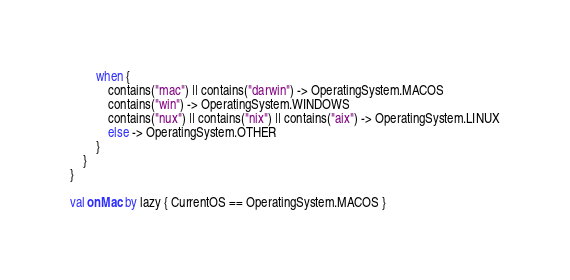<code> <loc_0><loc_0><loc_500><loc_500><_Kotlin_>        when {
            contains("mac") || contains("darwin") -> OperatingSystem.MACOS
            contains("win") -> OperatingSystem.WINDOWS
            contains("nux") || contains("nix") || contains("aix") -> OperatingSystem.LINUX
            else -> OperatingSystem.OTHER
        }
    }
}

val onMac by lazy { CurrentOS == OperatingSystem.MACOS }</code> 